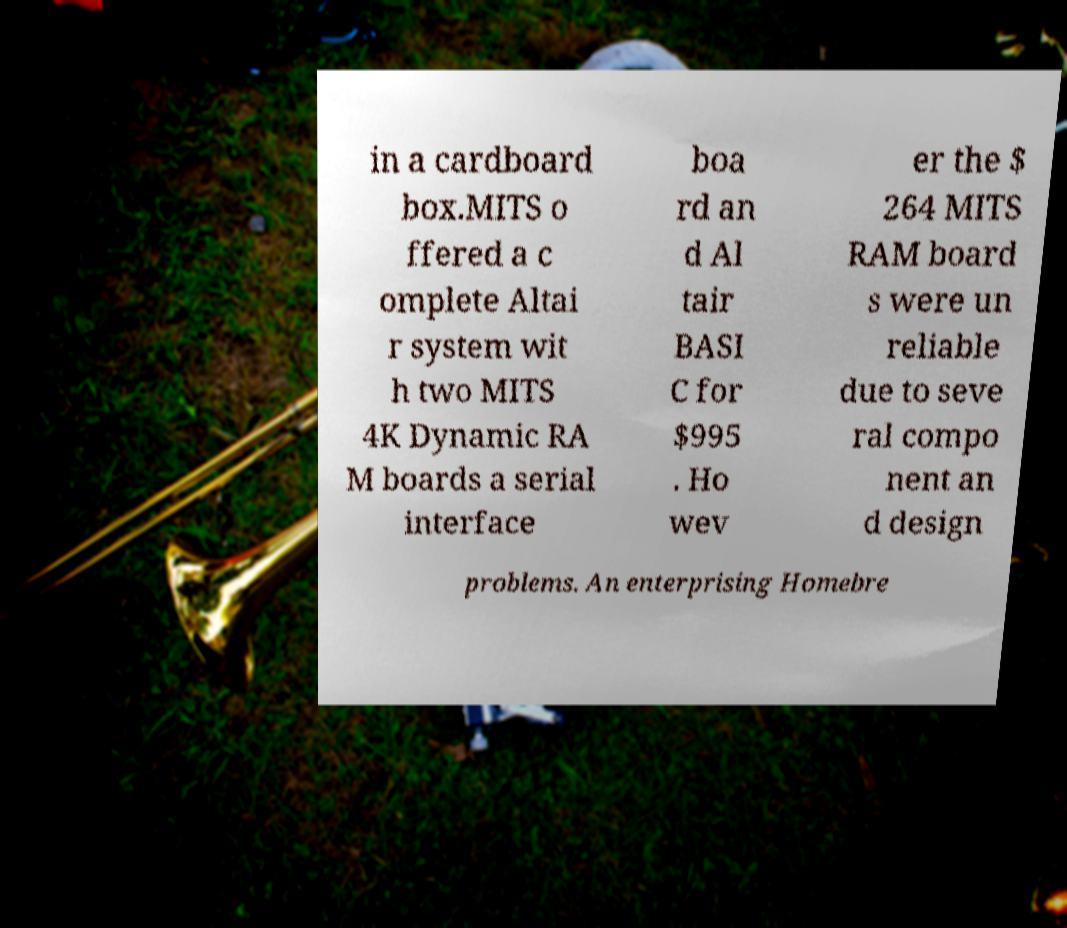Please read and relay the text visible in this image. What does it say? in a cardboard box.MITS o ffered a c omplete Altai r system wit h two MITS 4K Dynamic RA M boards a serial interface boa rd an d Al tair BASI C for $995 . Ho wev er the $ 264 MITS RAM board s were un reliable due to seve ral compo nent an d design problems. An enterprising Homebre 